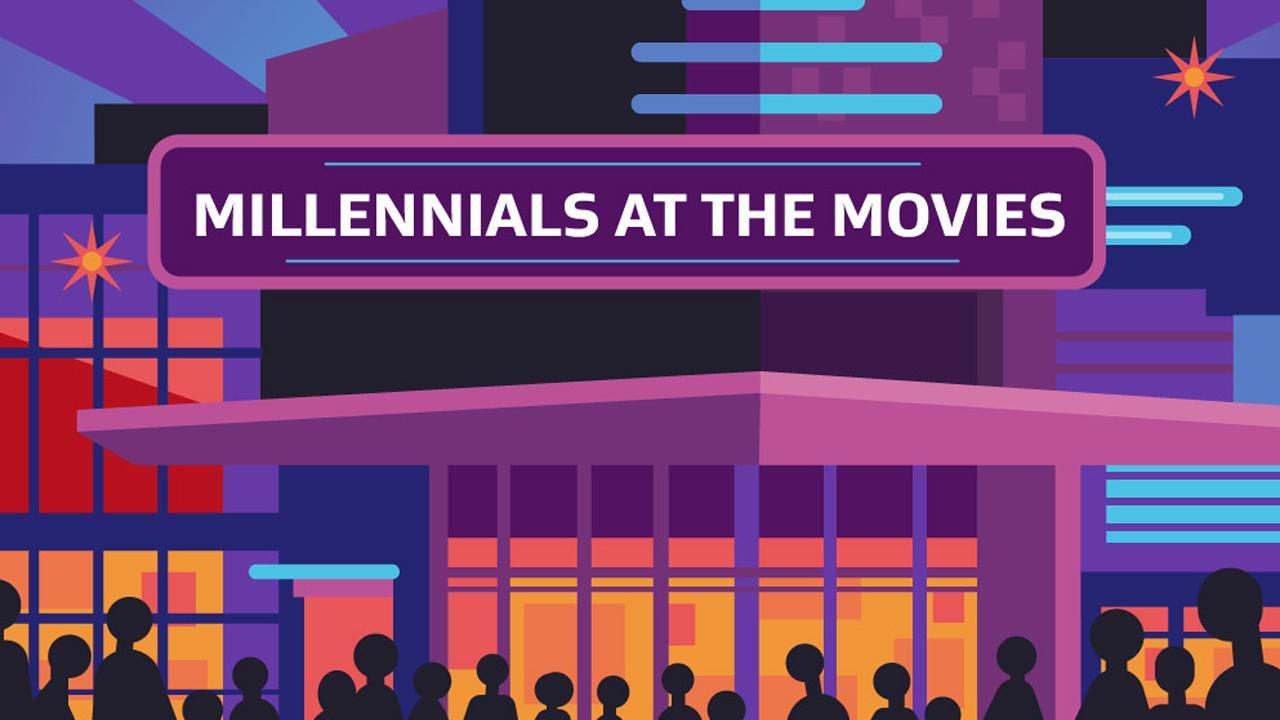Which color is not there in the infographic, yellow, green or blue?
Answer the question with a short phrase. green which color is predominantly used, purple, red or blue? purple 